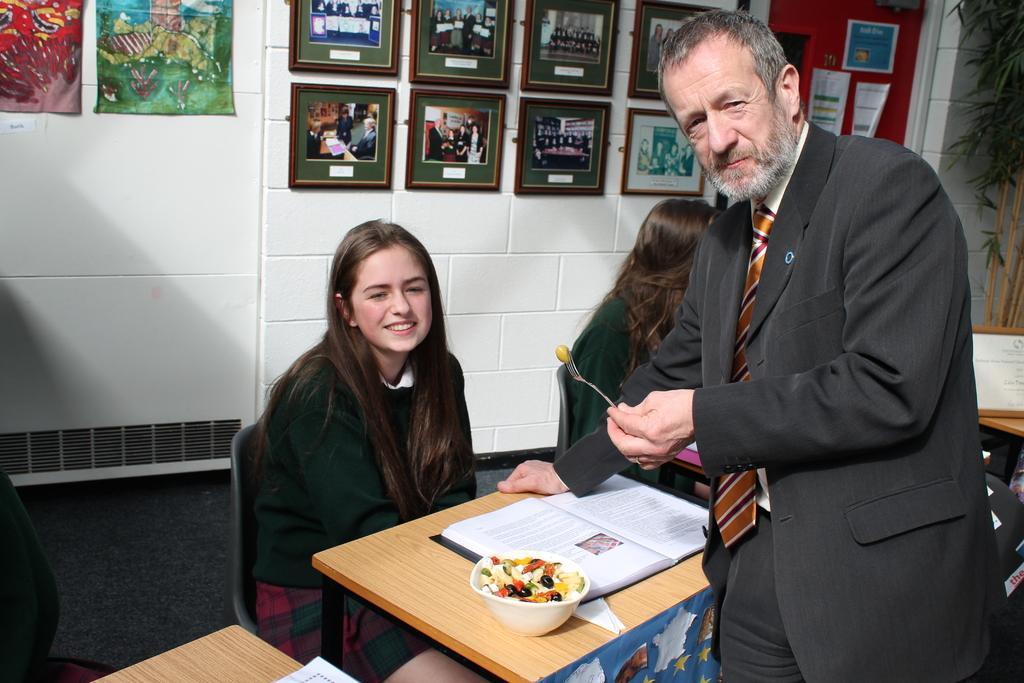How would you summarize this image in a sentence or two? On wall there are different type of posters and photos. This 2 women are sitting on a chair. On this table there is a book, bowl and fruits. This man is standing wore suit and holding a fork. This is plant. 